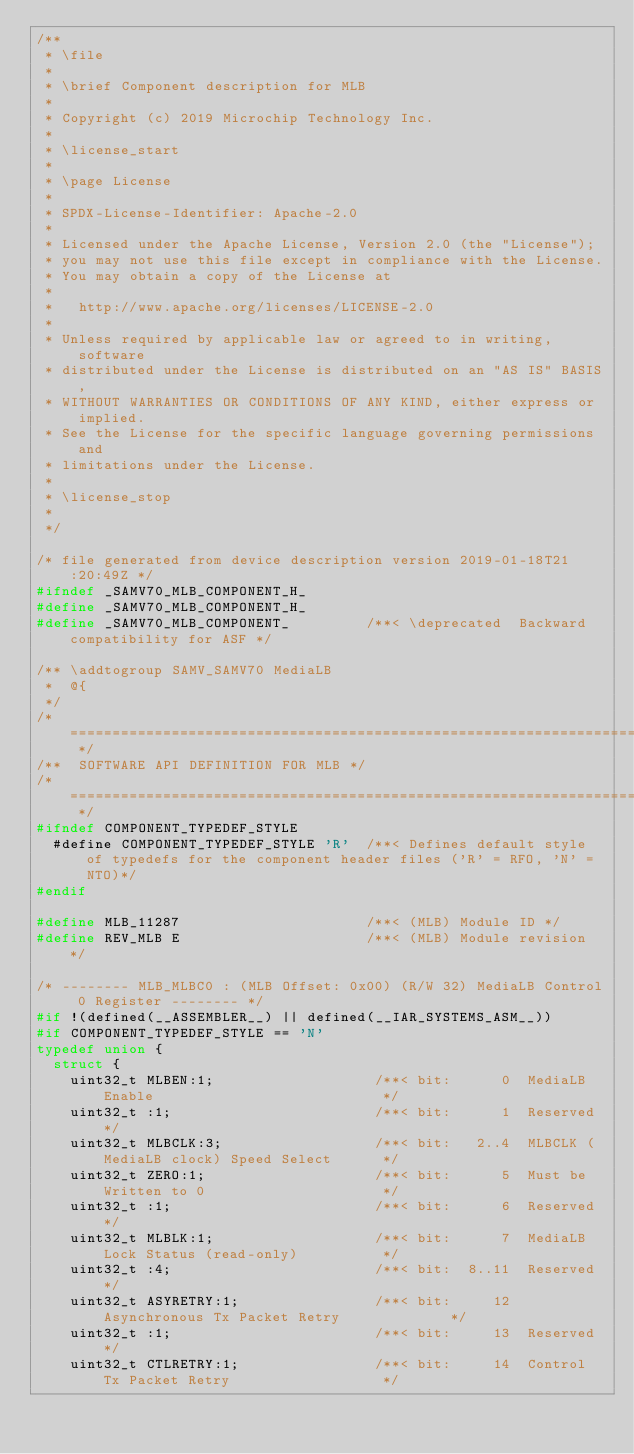Convert code to text. <code><loc_0><loc_0><loc_500><loc_500><_C_>/**
 * \file
 *
 * \brief Component description for MLB
 *
 * Copyright (c) 2019 Microchip Technology Inc.
 *
 * \license_start
 *
 * \page License
 *
 * SPDX-License-Identifier: Apache-2.0
 *
 * Licensed under the Apache License, Version 2.0 (the "License");
 * you may not use this file except in compliance with the License.
 * You may obtain a copy of the License at
 *
 *   http://www.apache.org/licenses/LICENSE-2.0
 *
 * Unless required by applicable law or agreed to in writing, software
 * distributed under the License is distributed on an "AS IS" BASIS,
 * WITHOUT WARRANTIES OR CONDITIONS OF ANY KIND, either express or implied.
 * See the License for the specific language governing permissions and
 * limitations under the License.
 *
 * \license_stop
 *
 */

/* file generated from device description version 2019-01-18T21:20:49Z */
#ifndef _SAMV70_MLB_COMPONENT_H_
#define _SAMV70_MLB_COMPONENT_H_
#define _SAMV70_MLB_COMPONENT_         /**< \deprecated  Backward compatibility for ASF */

/** \addtogroup SAMV_SAMV70 MediaLB
 *  @{
 */
/* ========================================================================== */
/**  SOFTWARE API DEFINITION FOR MLB */
/* ========================================================================== */
#ifndef COMPONENT_TYPEDEF_STYLE
  #define COMPONENT_TYPEDEF_STYLE 'R'  /**< Defines default style of typedefs for the component header files ('R' = RFO, 'N' = NTO)*/
#endif

#define MLB_11287                      /**< (MLB) Module ID */
#define REV_MLB E                      /**< (MLB) Module revision */

/* -------- MLB_MLBC0 : (MLB Offset: 0x00) (R/W 32) MediaLB Control 0 Register -------- */
#if !(defined(__ASSEMBLER__) || defined(__IAR_SYSTEMS_ASM__))
#if COMPONENT_TYPEDEF_STYLE == 'N'
typedef union { 
  struct {
    uint32_t MLBEN:1;                   /**< bit:      0  MediaLB Enable                           */
    uint32_t :1;                        /**< bit:      1  Reserved */
    uint32_t MLBCLK:3;                  /**< bit:   2..4  MLBCLK (MediaLB clock) Speed Select      */
    uint32_t ZERO:1;                    /**< bit:      5  Must be Written to 0                     */
    uint32_t :1;                        /**< bit:      6  Reserved */
    uint32_t MLBLK:1;                   /**< bit:      7  MediaLB Lock Status (read-only)          */
    uint32_t :4;                        /**< bit:  8..11  Reserved */
    uint32_t ASYRETRY:1;                /**< bit:     12  Asynchronous Tx Packet Retry             */
    uint32_t :1;                        /**< bit:     13  Reserved */
    uint32_t CTLRETRY:1;                /**< bit:     14  Control Tx Packet Retry                  */</code> 